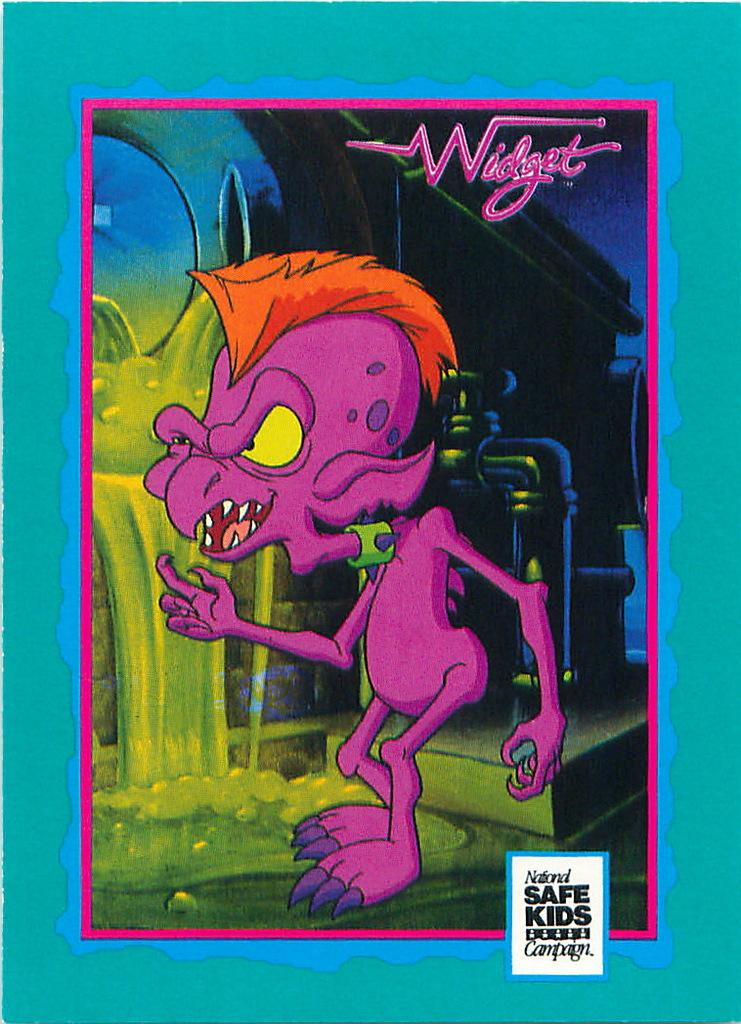<image>
Offer a succinct explanation of the picture presented. A purple creature is above a box that says National Safe Kids  Campaign. 